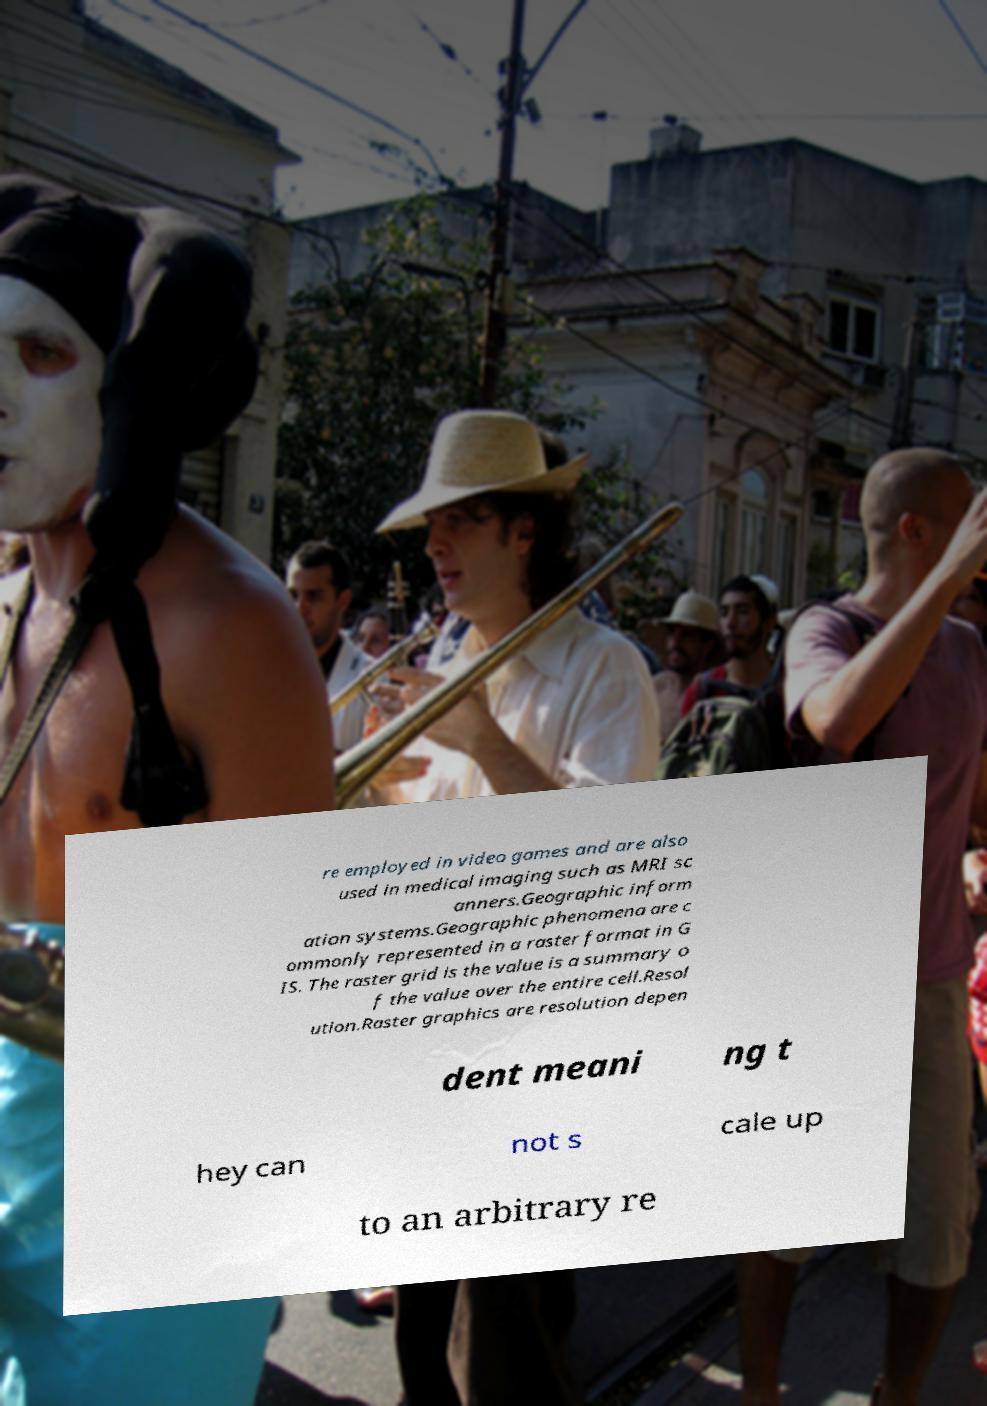Can you accurately transcribe the text from the provided image for me? re employed in video games and are also used in medical imaging such as MRI sc anners.Geographic inform ation systems.Geographic phenomena are c ommonly represented in a raster format in G IS. The raster grid is the value is a summary o f the value over the entire cell.Resol ution.Raster graphics are resolution depen dent meani ng t hey can not s cale up to an arbitrary re 